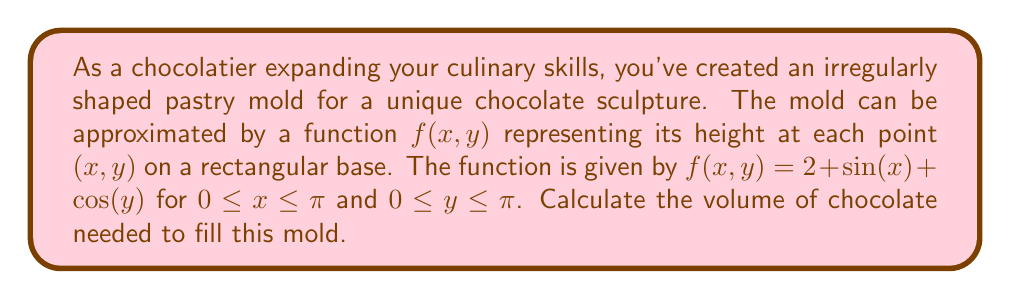Help me with this question. To calculate the volume of the irregularly shaped pastry mold, we need to use a double integral. The volume is given by the integral of the function $f(x,y)$ over the rectangular region defined by $0 \leq x \leq \pi$ and $0 \leq y \leq \pi$.

The steps to solve this problem are as follows:

1) Set up the double integral:
   $$V = \int_0^\pi \int_0^\pi f(x,y) \, dy \, dx$$

2) Substitute the given function:
   $$V = \int_0^\pi \int_0^\pi (2 + \sin(x) + \cos(y)) \, dy \, dx$$

3) Separate the integral:
   $$V = \int_0^\pi \int_0^\pi 2 \, dy \, dx + \int_0^\pi \int_0^\pi \sin(x) \, dy \, dx + \int_0^\pi \int_0^\pi \cos(y) \, dy \, dx$$

4) Evaluate each part:
   a) $\int_0^\pi \int_0^\pi 2 \, dy \, dx = 2\pi^2$
   
   b) $\int_0^\pi \int_0^\pi \sin(x) \, dy \, dx = \pi \int_0^\pi \sin(x) \, dx = \pi [-\cos(x)]_0^\pi = 2\pi$
   
   c) $\int_0^\pi \int_0^\pi \cos(y) \, dy \, dx = \pi \int_0^\pi \cos(y) \, dy = \pi [\sin(y)]_0^\pi = 0$

5) Sum the results:
   $$V = 2\pi^2 + 2\pi + 0 = 2\pi(\pi + 1)$$

Therefore, the volume of the pastry mold is $2\pi(\pi + 1)$ cubic units.
Answer: $2\pi(\pi + 1)$ cubic units 